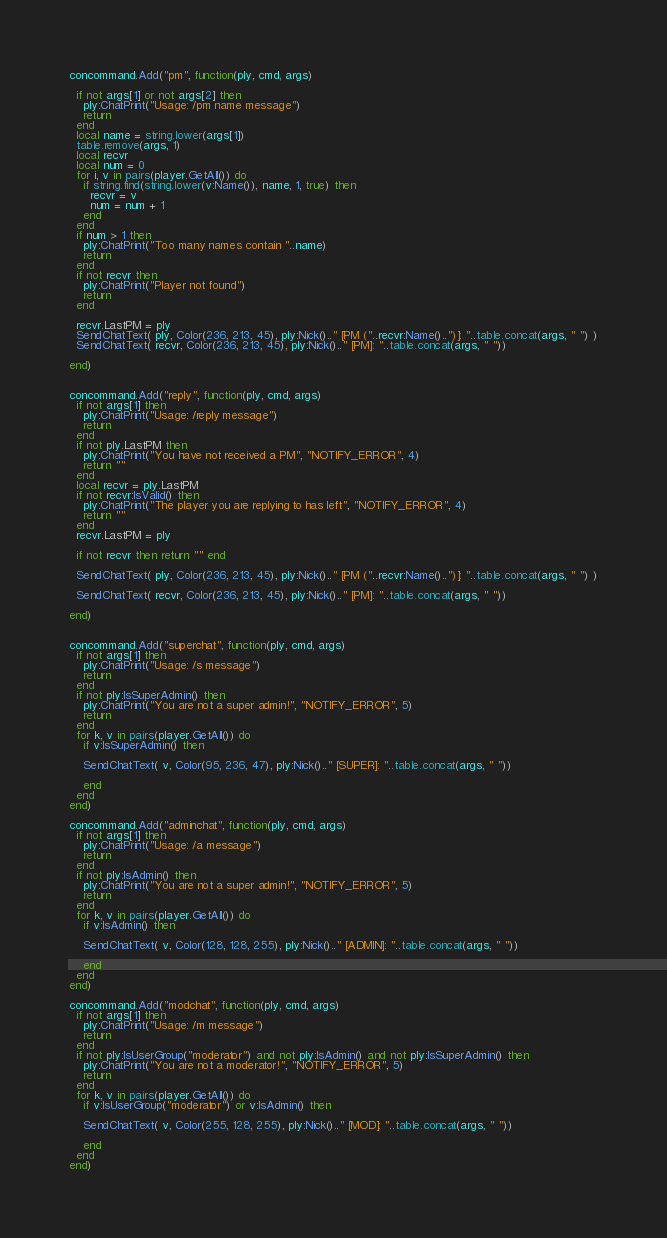<code> <loc_0><loc_0><loc_500><loc_500><_Lua_>concommand.Add("pm", function(ply, cmd, args)

  if not args[1] or not args[2] then 
    ply:ChatPrint("Usage: /pm name message") 
    return 
  end
  local name = string.lower(args[1])
  table.remove(args, 1)
  local recvr
  local num = 0
  for i, v in pairs(player.GetAll()) do 
    if string.find(string.lower(v:Name()), name, 1, true) then
      recvr = v
      num = num + 1
    end
  end
  if num > 1 then 
    ply:ChatPrint("Too many names contain "..name) 
    return 
  end
  if not recvr then
    ply:ChatPrint("Player not found")
    return 
  end
  
  recvr.LastPM = ply
  SendChatText( ply, Color(236, 213, 45), ply:Nick().." [PM ("..recvr:Name()..")]: "..table.concat(args, " ") )
  SendChatText( recvr, Color(236, 213, 45), ply:Nick().." [PM]: "..table.concat(args, " "))

end)


concommand.Add("reply", function(ply, cmd, args)
  if not args[1] then 
    ply:ChatPrint("Usage: /reply message") 
    return 
  end
  if not ply.LastPM then
    ply:ChatPrint("You have not received a PM", "NOTIFY_ERROR", 4)
    return "" 
  end
  local recvr = ply.LastPM
  if not recvr:IsValid() then 
    ply:ChatPrint("The player you are replying to has left", "NOTIFY_ERROR", 4)
    return "" 
  end
  recvr.LastPM = ply
  
  if not recvr then return "" end
  
  SendChatText( ply, Color(236, 213, 45), ply:Nick().." [PM ("..recvr:Name()..")]: "..table.concat(args, " ") )
  
  SendChatText( recvr, Color(236, 213, 45), ply:Nick().." [PM]: "..table.concat(args, " "))
  
end)


concommand.Add("superchat", function(ply, cmd, args)
  if not args[1] then 
    ply:ChatPrint("Usage: /s message") 
    return 
  end
  if not ply:IsSuperAdmin() then 
    ply:ChatPrint("You are not a super admin!", "NOTIFY_ERROR", 5) 
    return 
  end
  for k, v in pairs(player.GetAll()) do
    if v:IsSuperAdmin() then
	
	SendChatText( v, Color(95, 236, 47), ply:Nick().." [SUPER]: "..table.concat(args, " "))
	
    end
  end
end)

concommand.Add("adminchat", function(ply, cmd, args)
  if not args[1] then 
    ply:ChatPrint("Usage: /a message") 
    return 
  end
  if not ply:IsAdmin() then 
    ply:ChatPrint("You are not a super admin!", "NOTIFY_ERROR", 5) 
    return 
  end
  for k, v in pairs(player.GetAll()) do
    if v:IsAdmin() then
	
	SendChatText( v, Color(128, 128, 255), ply:Nick().." [ADMIN]: "..table.concat(args, " "))
	
    end
  end
end)

concommand.Add("modchat", function(ply, cmd, args)
  if not args[1] then 
    ply:ChatPrint("Usage: /m message") 
    return 
  end
  if not ply:IsUserGroup("moderator") and not ply:IsAdmin() and not ply:IsSuperAdmin() then 
    ply:ChatPrint("You are not a moderator!", "NOTIFY_ERROR", 5) 
    return 
  end
  for k, v in pairs(player.GetAll()) do
    if v:IsUserGroup("moderator") or v:IsAdmin() then
	
	SendChatText( v, Color(255, 128, 255), ply:Nick().." [MOD]: "..table.concat(args, " "))
	
    end
  end
end)
</code> 